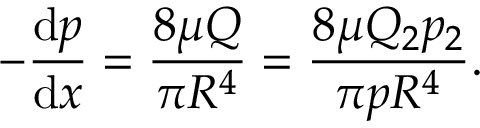Convert formula to latex. <formula><loc_0><loc_0><loc_500><loc_500>- { \frac { d p } { d x } } = { \frac { 8 \mu Q } { \pi R ^ { 4 } } } = { \frac { 8 \mu Q _ { 2 } p _ { 2 } } { \pi p R ^ { 4 } } } .</formula> 